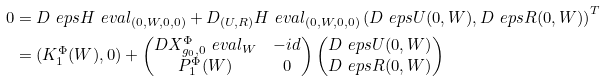Convert formula to latex. <formula><loc_0><loc_0><loc_500><loc_500>0 & = D _ { \ } e p s H \ e v a l _ { ( 0 , W , 0 , 0 ) } + D _ { ( U , R ) } H \ e v a l _ { ( 0 , W , 0 , 0 ) } \left ( D _ { \ } e p s U ( 0 , W ) , D _ { \ } e p s R ( 0 , W ) \right ) ^ { T } \\ & = ( K _ { 1 } ^ { \Phi } ( W ) , 0 ) + \begin{pmatrix} D X _ { g _ { 0 } , 0 } ^ { \Phi } \ e v a l _ { W } & - i d \\ P _ { 1 } ^ { \Phi } ( W ) & 0 \end{pmatrix} \begin{pmatrix} D _ { \ } e p s U ( 0 , W ) \\ D _ { \ } e p s R ( 0 , W ) \end{pmatrix}</formula> 